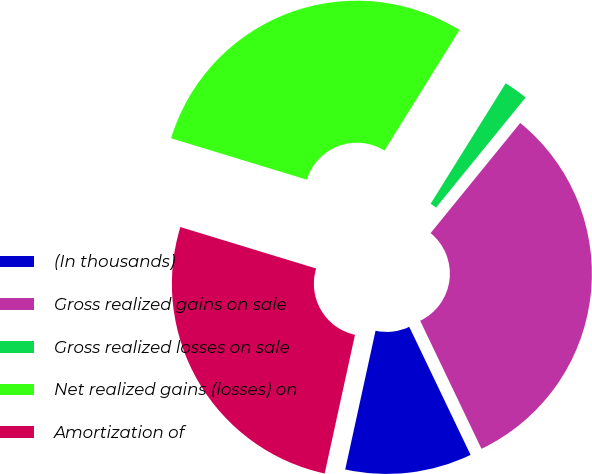<chart> <loc_0><loc_0><loc_500><loc_500><pie_chart><fcel>(In thousands)<fcel>Gross realized gains on sale<fcel>Gross realized losses on sale<fcel>Net realized gains (losses) on<fcel>Amortization of<nl><fcel>10.53%<fcel>32.02%<fcel>2.01%<fcel>29.15%<fcel>26.29%<nl></chart> 